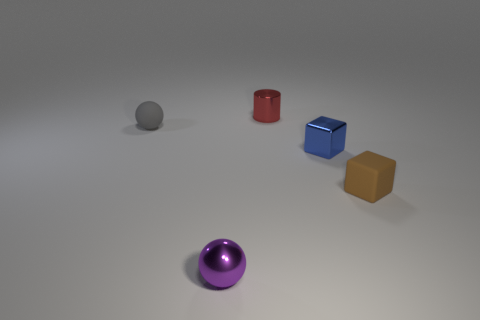What is the color of the matte thing left of the tiny brown object?
Your answer should be compact. Gray. Do the cylinder and the small metal cube have the same color?
Your answer should be very brief. No. There is a matte thing that is left of the tiny object that is on the right side of the blue shiny thing; how many gray rubber objects are in front of it?
Give a very brief answer. 0. How big is the blue object?
Your answer should be very brief. Small. What material is the purple sphere that is the same size as the shiny cube?
Your answer should be compact. Metal. There is a tiny purple shiny sphere; how many brown blocks are left of it?
Give a very brief answer. 0. Are the tiny purple thing that is left of the small red cylinder and the tiny object that is to the left of the small purple object made of the same material?
Make the answer very short. No. There is a matte object in front of the rubber object that is on the left side of the small ball in front of the matte ball; what is its shape?
Make the answer very short. Cube. The gray thing has what shape?
Keep it short and to the point. Sphere. The blue object that is the same size as the matte block is what shape?
Your answer should be very brief. Cube. 